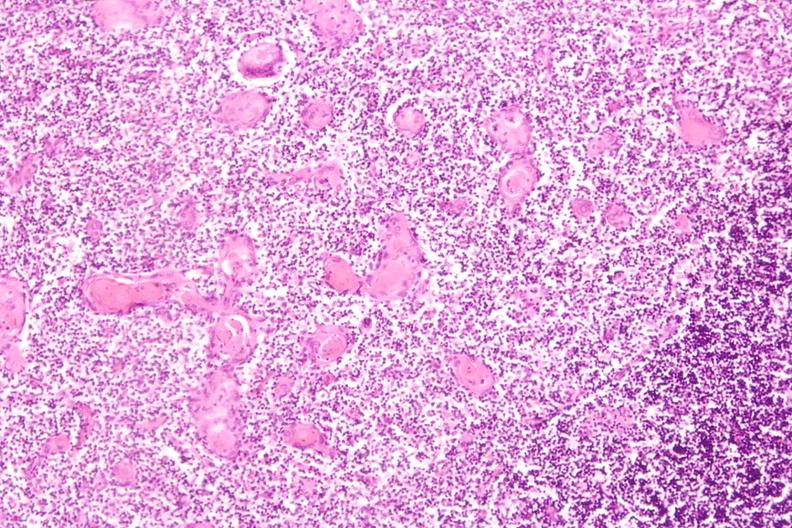what is present?
Answer the question using a single word or phrase. Hematologic 